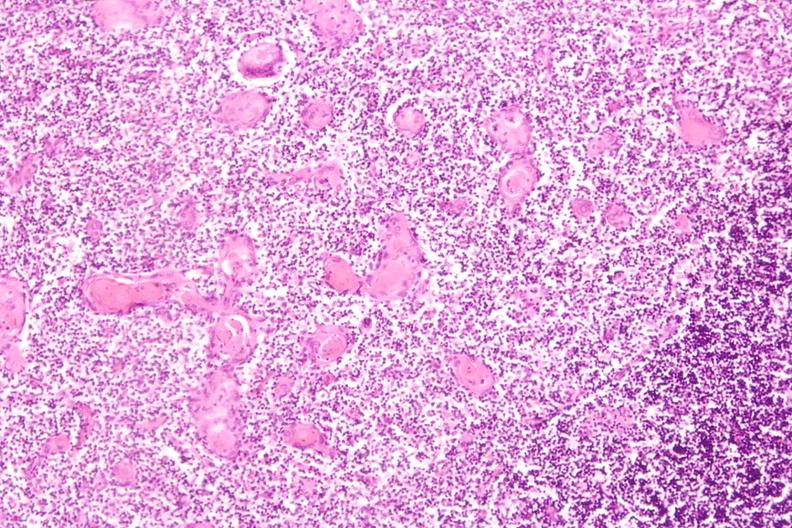what is present?
Answer the question using a single word or phrase. Hematologic 